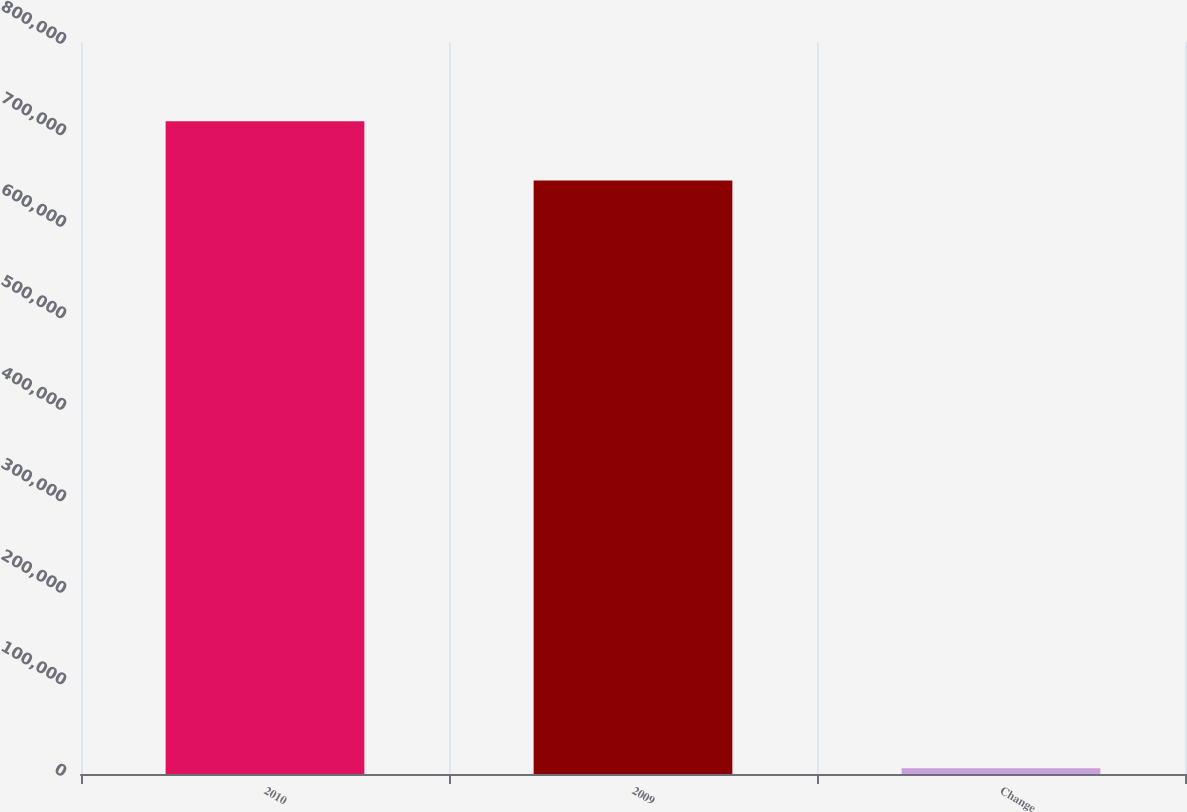Convert chart to OTSL. <chart><loc_0><loc_0><loc_500><loc_500><bar_chart><fcel>2010<fcel>2009<fcel>Change<nl><fcel>713359<fcel>648508<fcel>6155<nl></chart> 